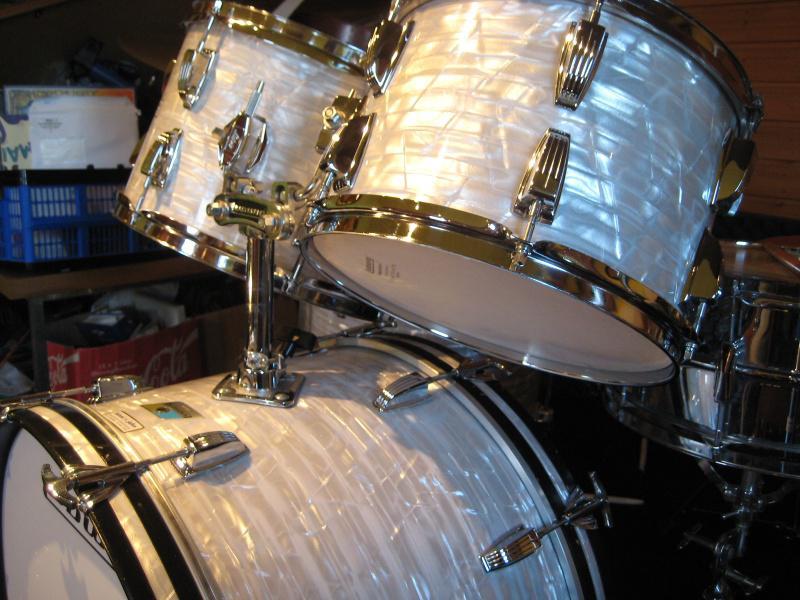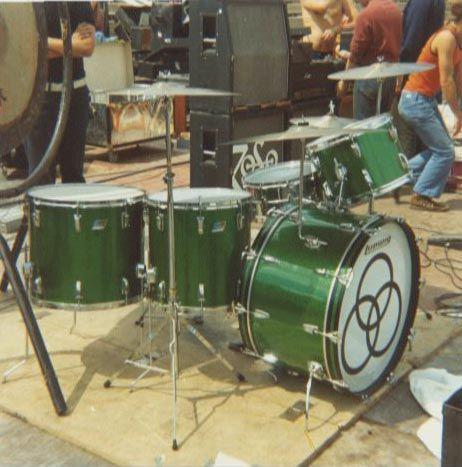The first image is the image on the left, the second image is the image on the right. For the images displayed, is the sentence "In at least one image there is a man playing a sliver drum set that is facing forward right." factually correct? Answer yes or no. No. The first image is the image on the left, the second image is the image on the right. Assess this claim about the two images: "The face of the large drum in the front is entirely visible in each image.". Correct or not? Answer yes or no. No. 